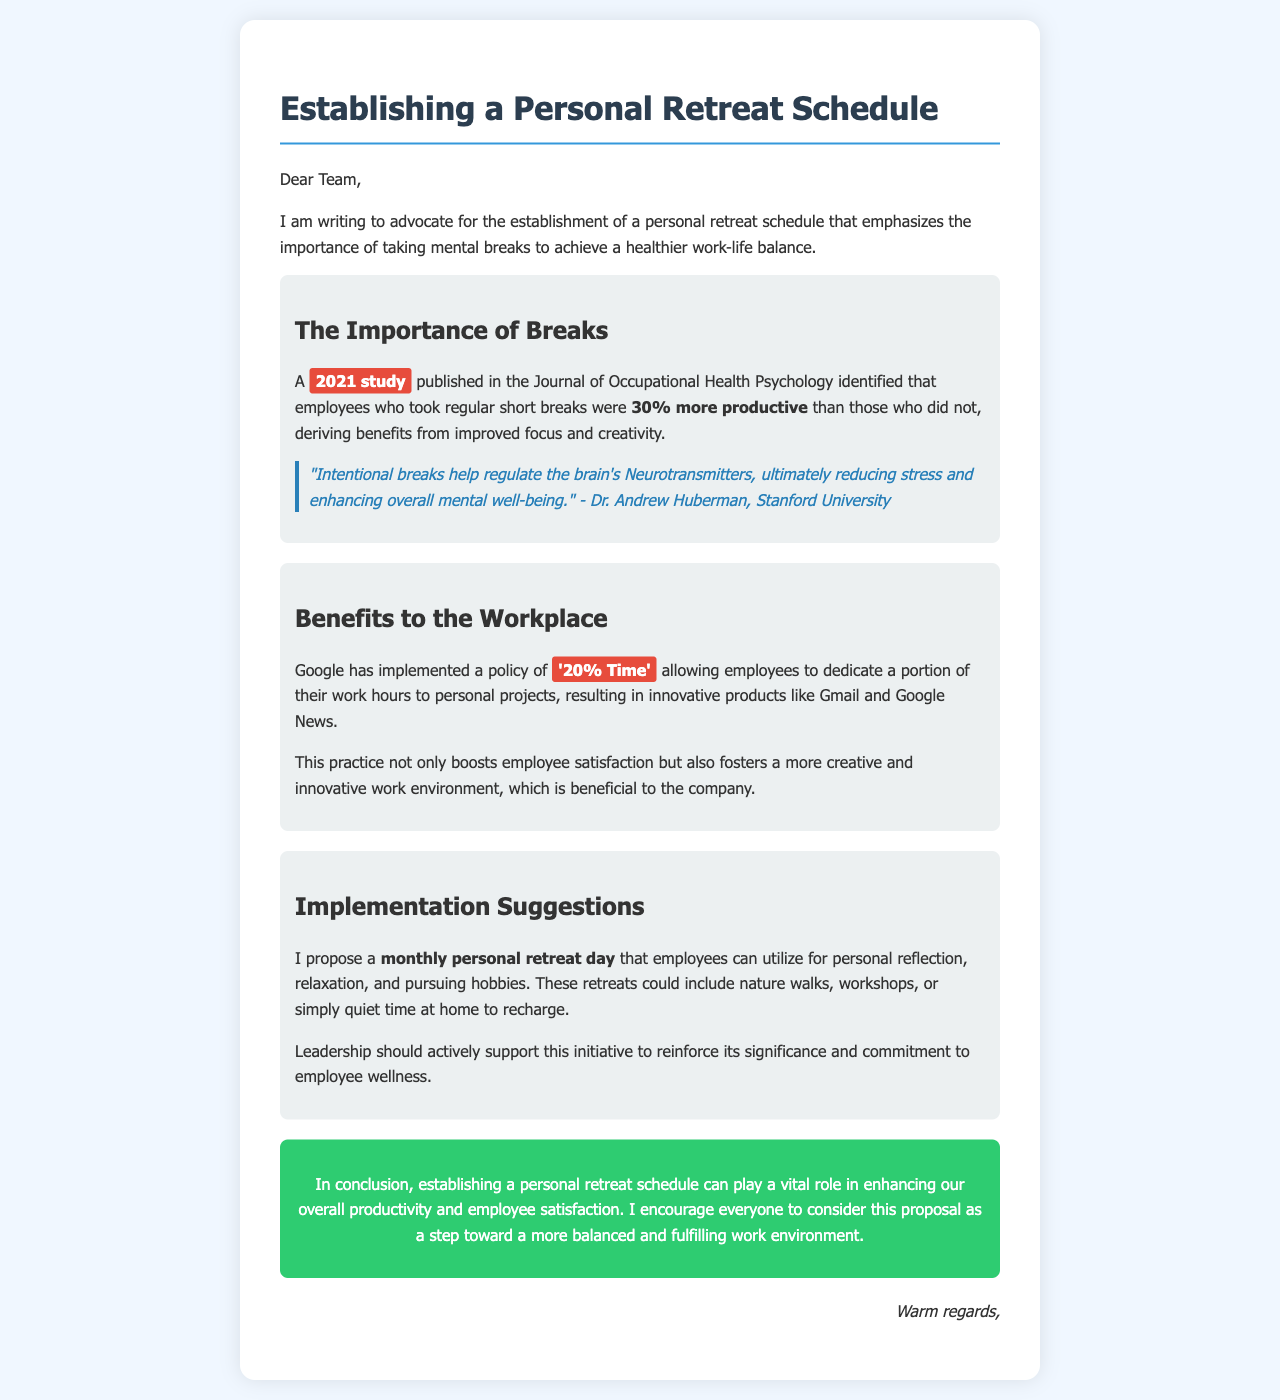What is the title of the document? The title of the document is found at the top of the letter.
Answer: Establishing a Personal Retreat Schedule Who published the study mentioned in the letter? The study mentioned is from a journal, which implies it has an author or organization associated with it.
Answer: Journal of Occupational Health Psychology What percentage more productive are employees who take breaks? The document provides a statistic regarding productivity in relation to taking breaks.
Answer: 30% What is Google's '20% Time'? This phrase is used to describe a company policy that allows employees to work on personal projects during work hours.
Answer: Personal projects What is one proposed activity for the personal retreat day? The document suggests activities that employees might engage in during their personal retreat day.
Answer: Nature walks What does Dr. Andrew Huberman emphasize in his quote? Dr. Huberman's quote highlights the effects of breaks on mental well-being.
Answer: Reducing stress How often is the personal retreat day proposed to occur? The proposed frequency of the personal retreat day is mentioned clearly in the document.
Answer: Monthly What is the primary purpose of the personal retreat schedule? The main objective of establishing this schedule is specified in the letter.
Answer: Achieving a healthier work-life balance What should leadership do to support this initiative? The document suggests a particular action that leadership should take to reinforce the new initiative.
Answer: Actively support 